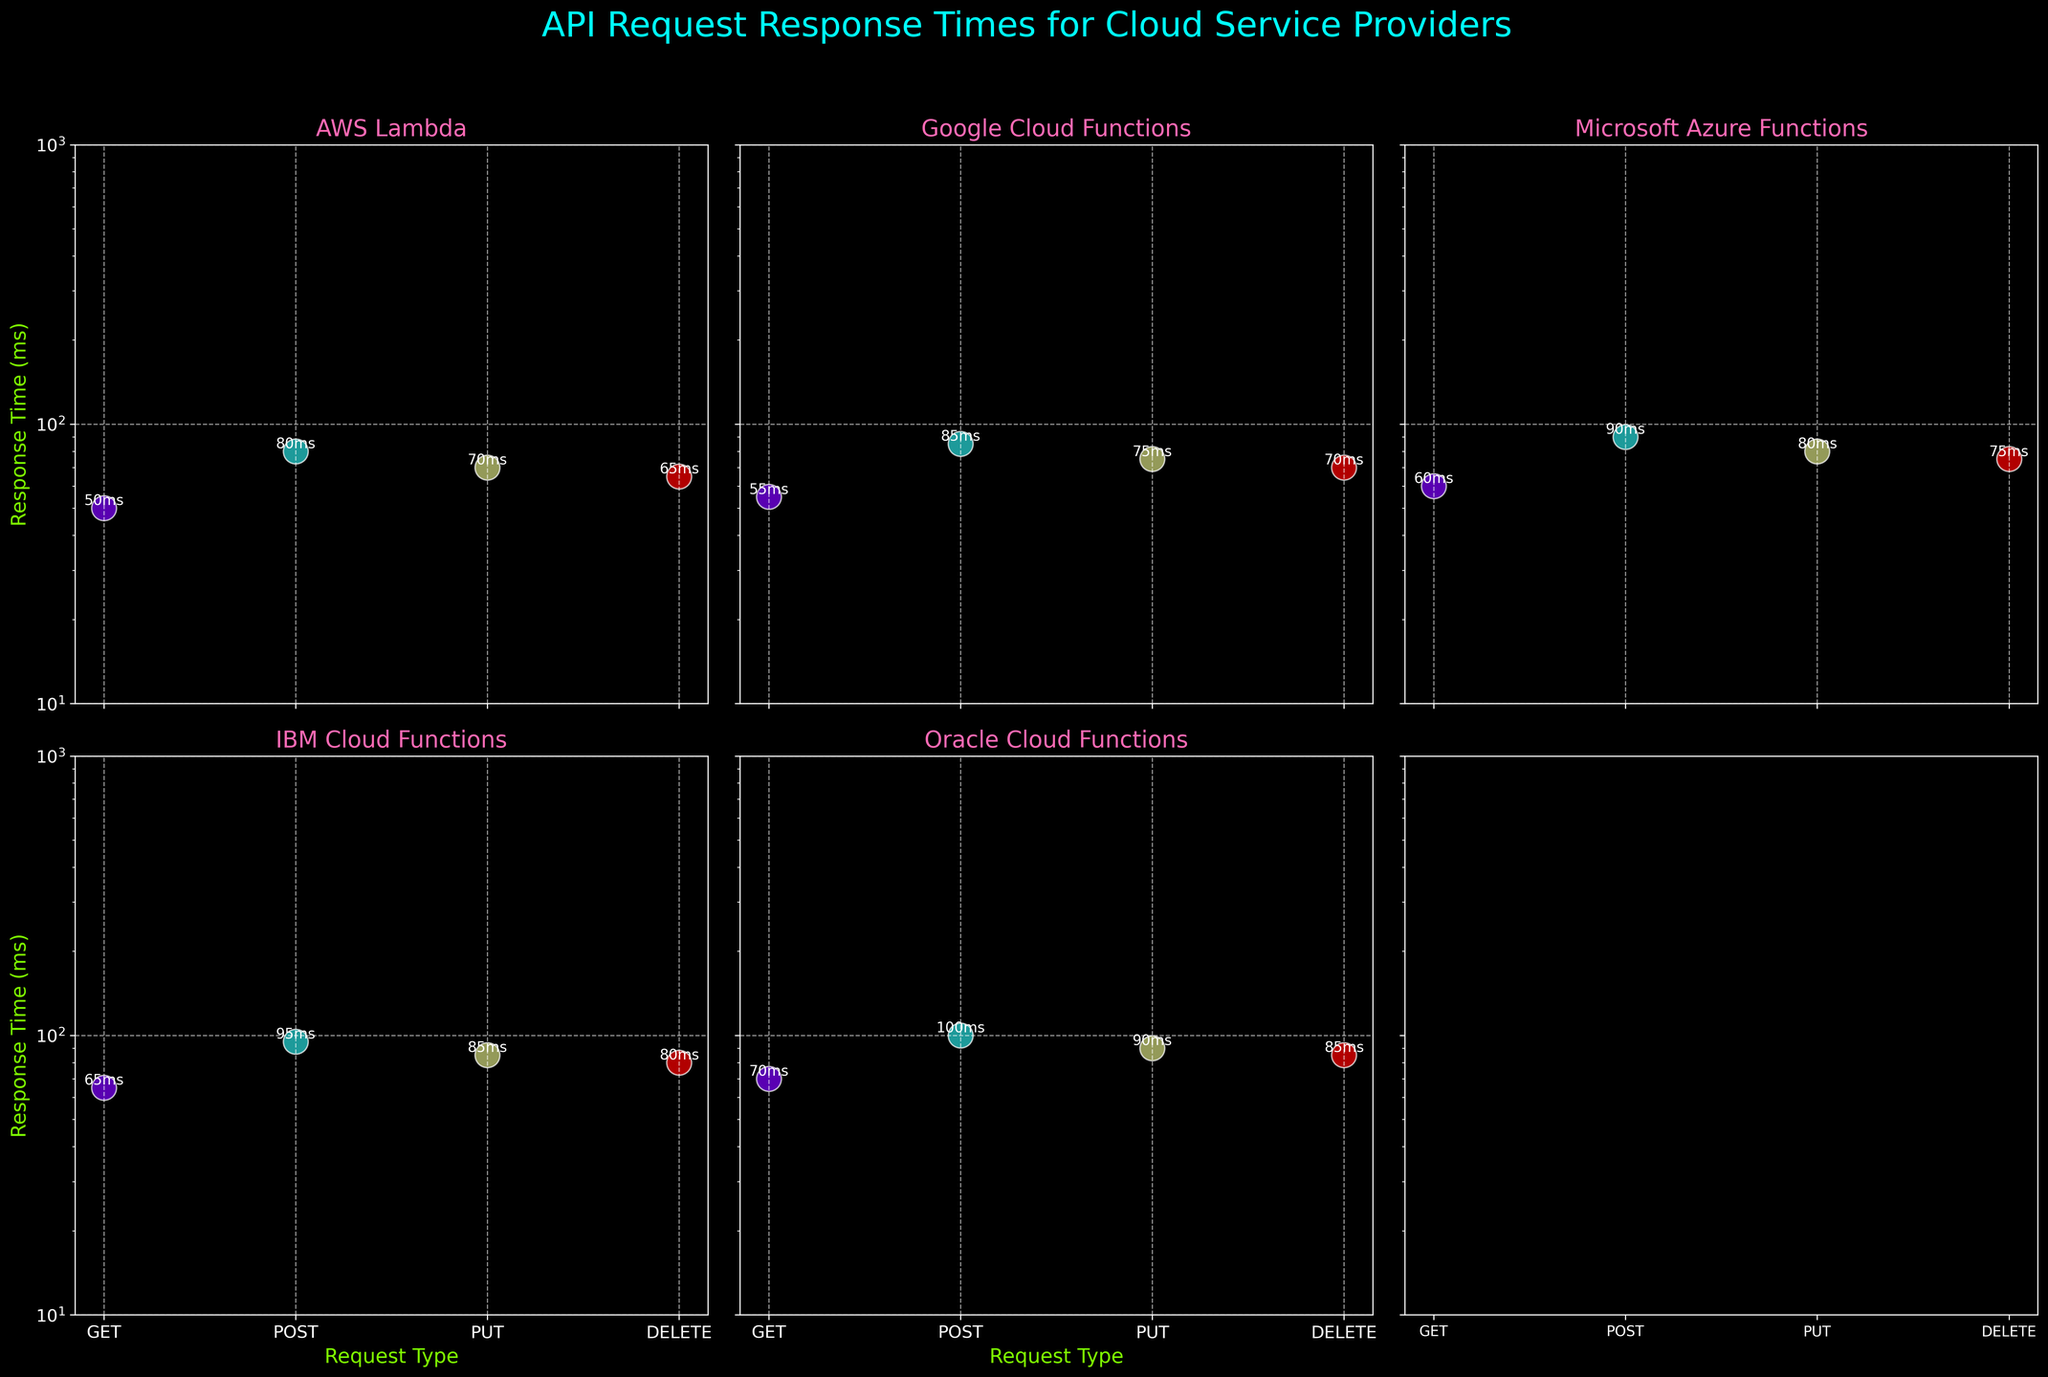Which cloud service provider has the highest response time for GET requests? Look at the y-axis value for GET requests across all subplots. The highest y-axis value for GET requests is visible on the Oracle Cloud Functions subplot.
Answer: Oracle Cloud Functions How many request types are displayed for each cloud service provider? Count the unique x-axis labels in any subplot. Each subplot shows the request types: GET, POST, PUT, DELETE.
Answer: 4 What is the fastest response time recorded, and which request type and cloud service provider does it belong to? Identify the lowest y-axis value across all subplots. The lowest value is at 50ms, found in the AWS Lambda subplot for the GET request.
Answer: AWS Lambda, GET Which request type has the most consistent response times across all providers? Compare the response times for each request type (GET, POST, PUT, DELETE) across all subplots. The DELETE request shows values with minor variations around 65-85ms across all providers.
Answer: DELETE How does the response time for PUT requests in Google Cloud Functions compare to that in Microsoft Azure Functions? Locate the PUT request markers for both Google Cloud Functions and Microsoft Azure Functions. Compare their y-axis values: Google has 75ms and Microsoft Azure has 80ms.
Answer: Google is faster by 5ms Which cloud service provider has the most varied response times across all request types? Check the range of response times in each subplot. The subplot with the widest range (i.e., the biggest difference between the highest and lowest response times) is Oracle Cloud Functions (70ms to 100ms).
Answer: Oracle Cloud Functions Which request type on IBM Cloud Functions has the slowest response time, and what is the value? Identify the highest y-axis value within the IBM Cloud Functions subplot. The slowest response time is for POST requests at 95ms.
Answer: POST, 95ms Is there any request type where AWS Lambda outperforms all other providers? Compare each request type's response times across subplots. AWS Lambda has the lowest GET request response time at 50ms, outperforming other providers in this category.
Answer: Yes, GET What is the average response time for POST requests across all providers? Sum the POST request response times from each subplot and divide by the number of providers. Calculations: (80 + 85 + 90 + 95 + 100) / 5 = 90ms.
Answer: 90ms Which cloud service provider has the closest response times for GET and DELETE requests? Examine the GET and DELETE response times for each provider. IBM Cloud Functions has 65ms for GET and 80ms for DELETE, a 15ms difference, which is relatively small compared to others.
Answer: IBM Cloud Functions 